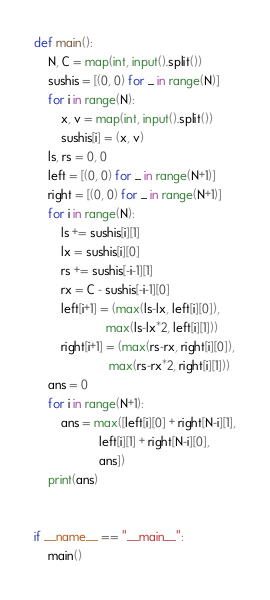<code> <loc_0><loc_0><loc_500><loc_500><_Python_>def main():
    N, C = map(int, input().split())
    sushis = [(0, 0) for _ in range(N)]
    for i in range(N):
        x, v = map(int, input().split())
        sushis[i] = (x, v)
    ls, rs = 0, 0
    left = [(0, 0) for _ in range(N+1)]
    right = [(0, 0) for _ in range(N+1)]
    for i in range(N):
        ls += sushis[i][1]
        lx = sushis[i][0]
        rs += sushis[-i-1][1]
        rx = C - sushis[-i-1][0]
        left[i+1] = (max(ls-lx, left[i][0]),
                     max(ls-lx*2, left[i][1]))
        right[i+1] = (max(rs-rx, right[i][0]),
                      max(rs-rx*2, right[i][1]))
    ans = 0
    for i in range(N+1):
        ans = max([left[i][0] + right[N-i][1],
                   left[i][1] + right[N-i][0],
                   ans])
    print(ans)


if __name__ == "__main__":
    main()
</code> 